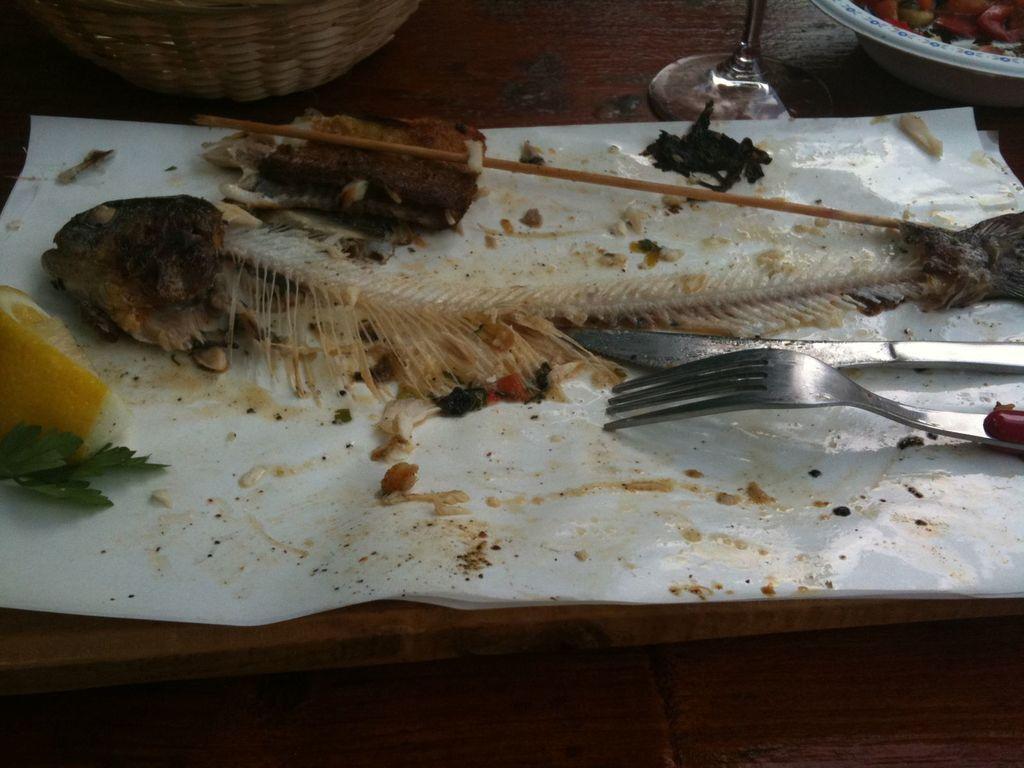Describe this image in one or two sentences. In this image in front there is a wooden table. On top of it there is a cover on which there is a fork. There is a knife. There is a slice of a lemon and there are food items. Beside the cover there is a glass. There are bowls. 